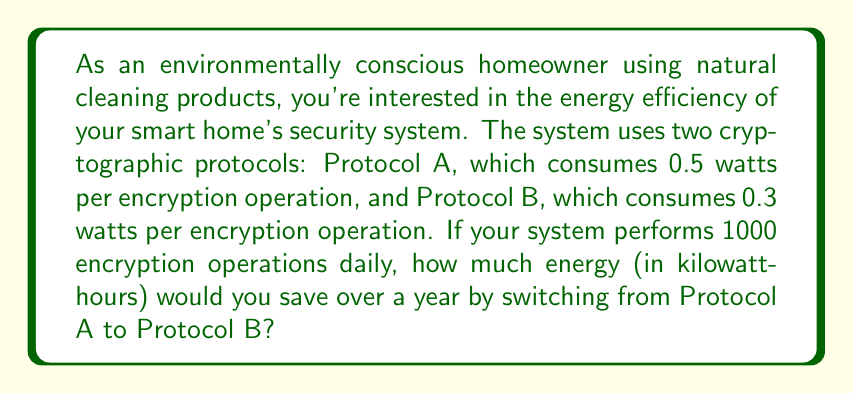Can you solve this math problem? Let's approach this step-by-step:

1) First, calculate the daily energy consumption for each protocol:
   Protocol A: $0.5 \text{ watts} \times 1000 \text{ operations} = 500 \text{ watt-hours}$
   Protocol B: $0.3 \text{ watts} \times 1000 \text{ operations} = 300 \text{ watt-hours}$

2) Calculate the daily energy savings:
   $500 \text{ watt-hours} - 300 \text{ watt-hours} = 200 \text{ watt-hours}$

3) Convert this to kilowatt-hours:
   $200 \text{ watt-hours} = 0.2 \text{ kilowatt-hours}$

4) Calculate the annual savings:
   $0.2 \text{ kWh} \times 365 \text{ days} = 73 \text{ kWh}$

Therefore, by switching from Protocol A to Protocol B, you would save 73 kilowatt-hours of energy over a year.
Answer: 73 kWh 